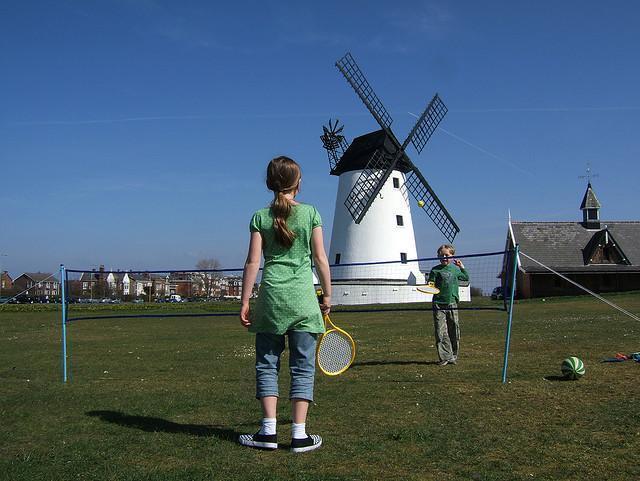How many people are in the photo?
Give a very brief answer. 2. How many sinks are sitting in this bathroom?
Give a very brief answer. 0. 